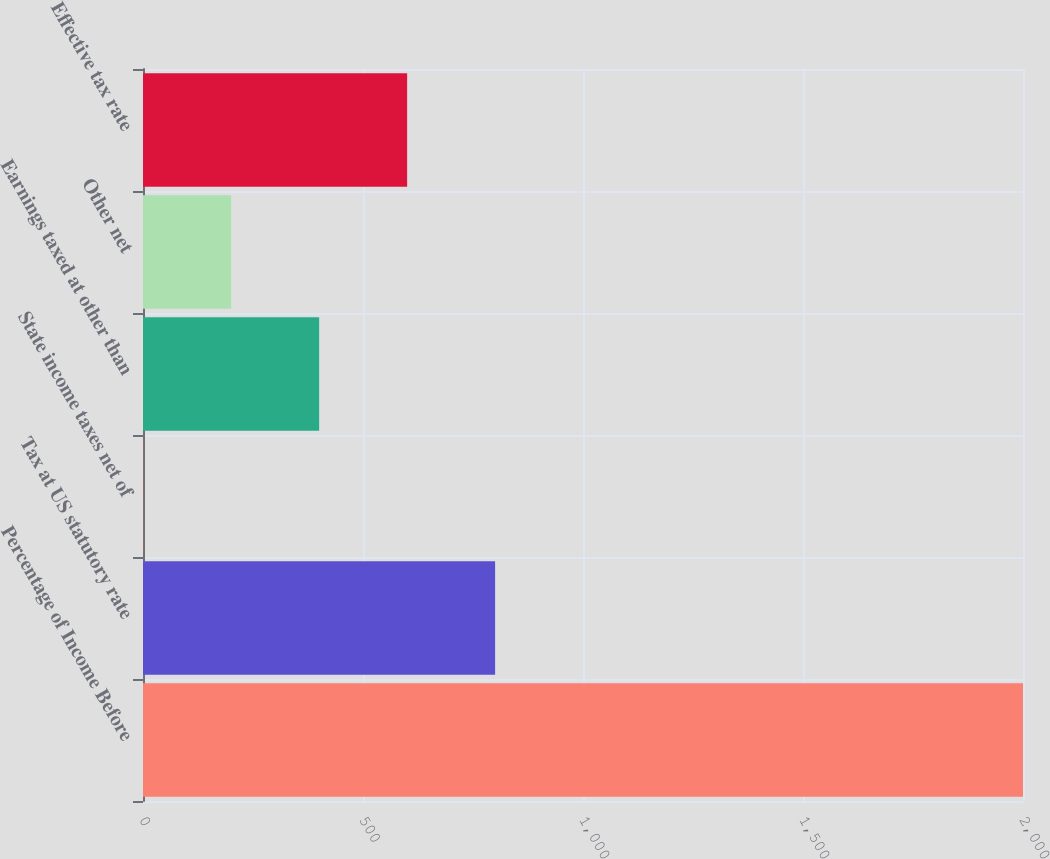<chart> <loc_0><loc_0><loc_500><loc_500><bar_chart><fcel>Percentage of Income Before<fcel>Tax at US statutory rate<fcel>State income taxes net of<fcel>Earnings taxed at other than<fcel>Other net<fcel>Effective tax rate<nl><fcel>2000<fcel>800.24<fcel>0.4<fcel>400.32<fcel>200.36<fcel>600.28<nl></chart> 